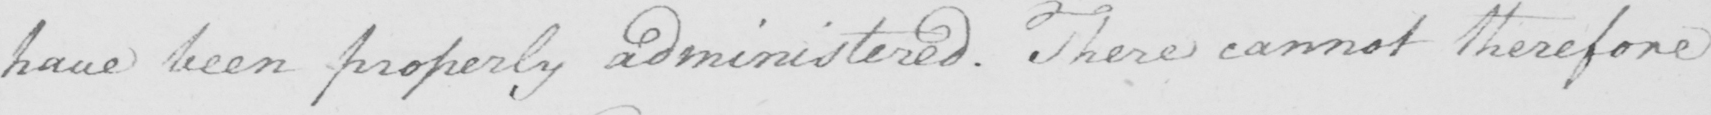What text is written in this handwritten line? have been properly administered. There cannot therefore 